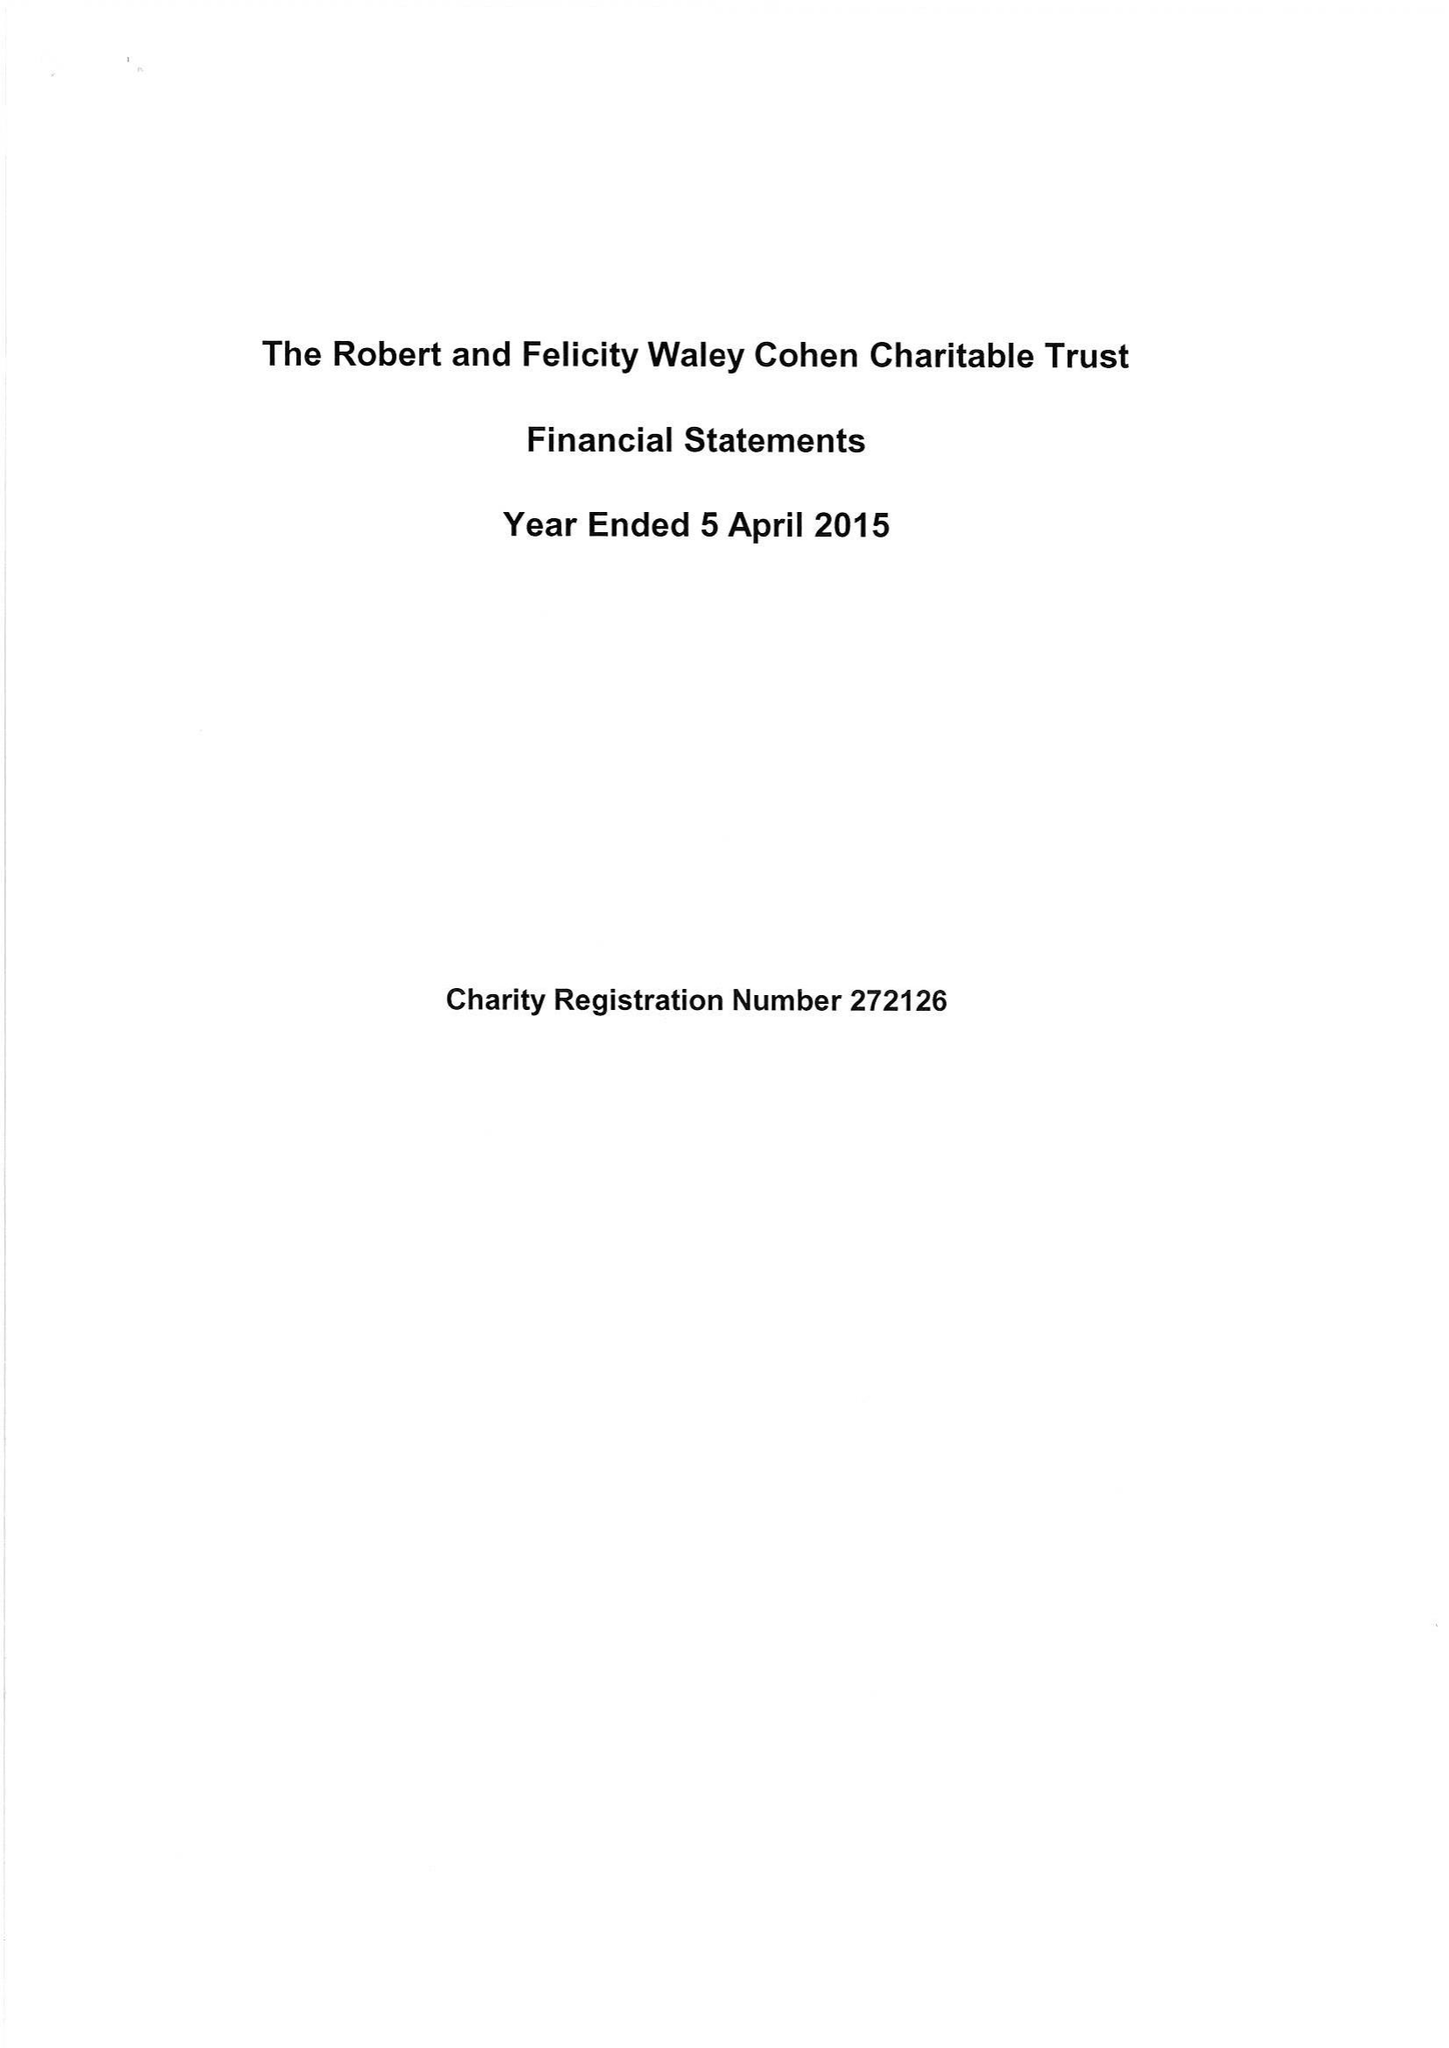What is the value for the charity_name?
Answer the question using a single word or phrase. Robert and Felicity Waley-Cohen Charitable Trust 